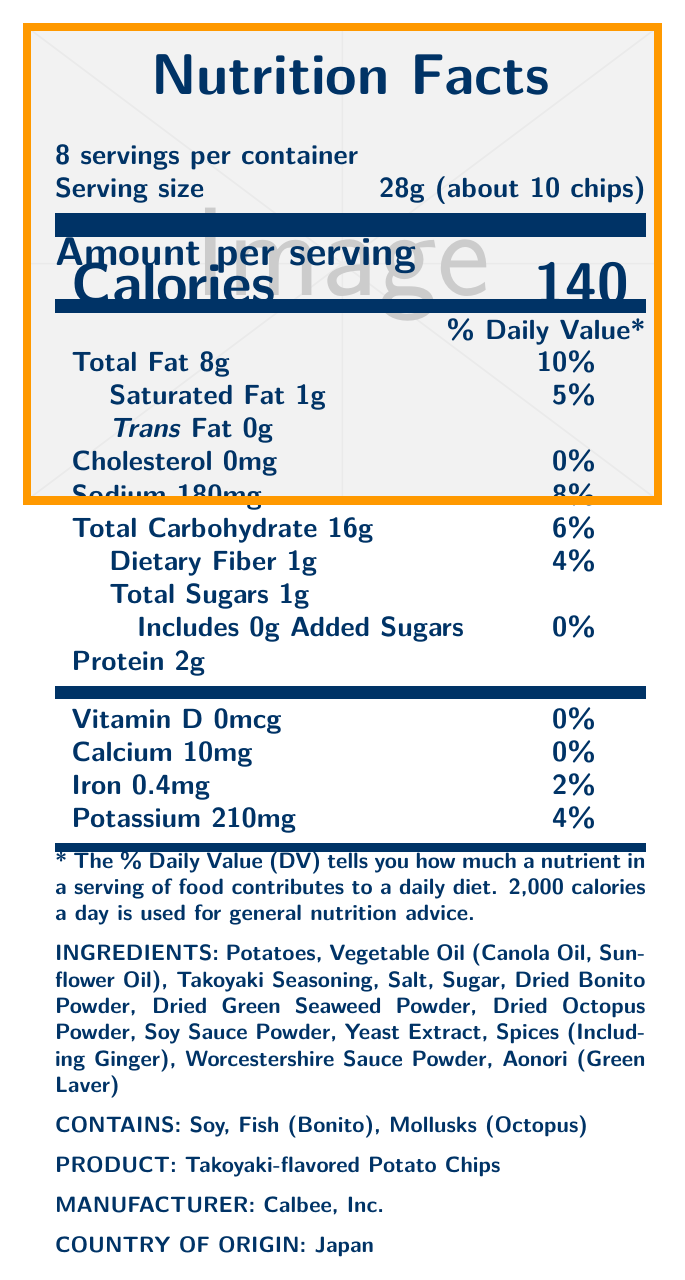what is the serving size of Takoyaki-flavored Potato Chips? The serving size is indicated as 28g and approximately 10 chips.
Answer: 28g (about 10 chips) how many calories are there per serving? The calorie content per serving is explicitly mentioned as 140.
Answer: 140 what ingredient gives a marine flavor to the chips? Dried Bonito Powder, Dried Octopus Powder, and Aonori (Green Laver) are ingredients listed that provide a marine flavor.
Answer: Dried Bonito Powder, Dried Octopus Powder, Aonori (Green Laver) what is the percent daily value of sodium per serving? The document states the percent daily value of sodium per serving as 8%.
Answer: 8% who is the manufacturer of the Takoyaki-flavored Potato Chips? The manufacturer listed in the document is Calbee, Inc.
Answer: Calbee, Inc. which of the following is not an ingredient in Takoyaki-flavored Potato Chips? A. Potatoes B. Vegetable Oil C. Sea Salt D. Yeast Extract The ingredients include regular salt but do not mention sea salt specifically.
Answer: C. Sea Salt how many total servings are in the container? A. 6 B. 8 C. 10 D. 12 The document states that there are 8 servings per container.
Answer: B. 8 does the product contain any added sugars? The added sugars amount is listed as 0g and the percent daily value as 0%.
Answer: No is the product suitable for someone allergic to soy? The allergen information indicates that the product contains soy.
Answer: No summarize the main information provided in the document. The document is a nutrition label that describes the nutritional content, ingredients, and allergen warnings for a Japanese snack, Takoyaki-flavored Potato Chips. Key nutritional information such as calories, fats, carbohydrates, and proteins per serving is listed along with the daily values. It also includes a list of ingredients and allergen information relevant to consumers.
Answer: The document provides the Nutrition Facts for Takoyaki-flavored Potato Chips manufactured by Calbee, Inc. in Japan. It details the serving size, calories, macronutrients, vitamins, minerals, ingredients, allergen information, and the number of servings per container. what is the re-order number for this product? The document does not provide any re-order number or identification code for the product.
Answer: Cannot be determined 